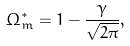Convert formula to latex. <formula><loc_0><loc_0><loc_500><loc_500>\Omega _ { m } ^ { * } = 1 - \frac { \gamma } { \sqrt { 2 \pi } } ,</formula> 